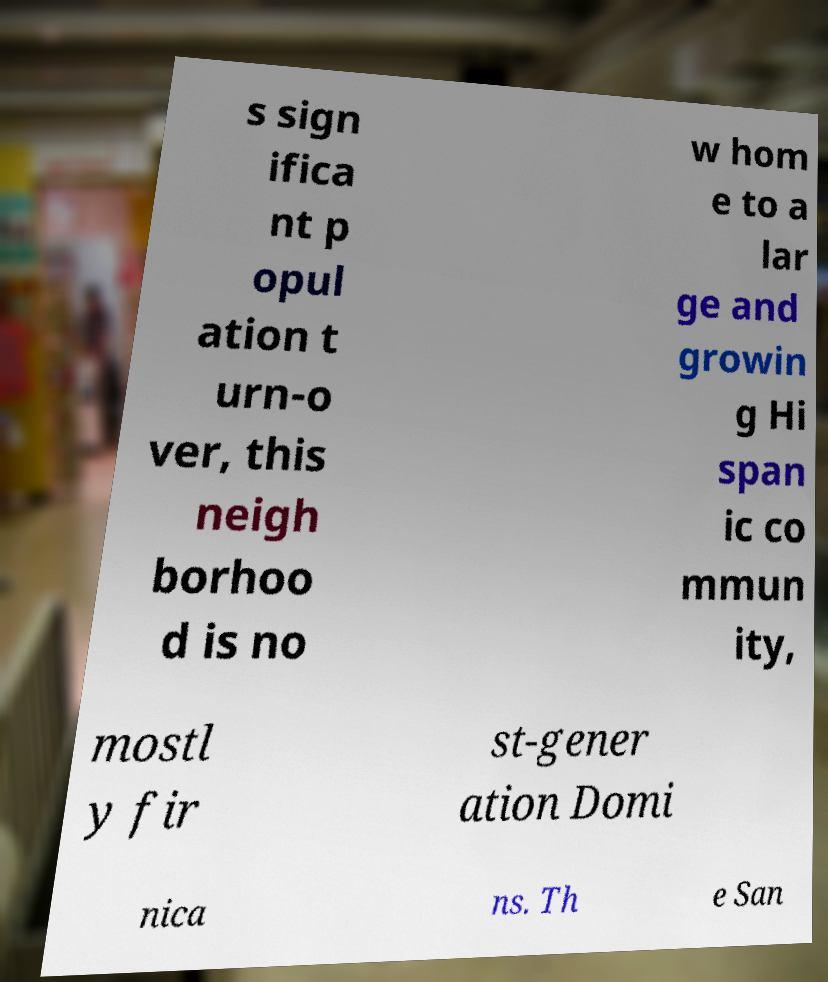Can you read and provide the text displayed in the image?This photo seems to have some interesting text. Can you extract and type it out for me? s sign ifica nt p opul ation t urn-o ver, this neigh borhoo d is no w hom e to a lar ge and growin g Hi span ic co mmun ity, mostl y fir st-gener ation Domi nica ns. Th e San 